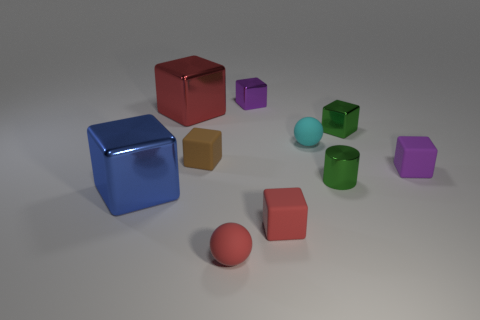Subtract all brown blocks. How many blocks are left? 6 Subtract all tiny green cubes. How many cubes are left? 6 Subtract all green cubes. Subtract all yellow balls. How many cubes are left? 6 Subtract all spheres. How many objects are left? 8 Subtract 0 purple balls. How many objects are left? 10 Subtract all tiny metallic spheres. Subtract all metal blocks. How many objects are left? 6 Add 2 green metallic blocks. How many green metallic blocks are left? 3 Add 6 cyan rubber balls. How many cyan rubber balls exist? 7 